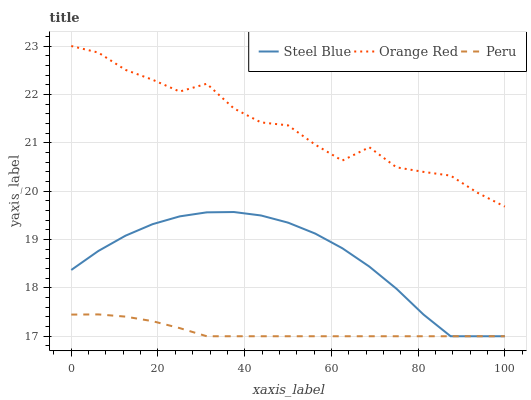Does Peru have the minimum area under the curve?
Answer yes or no. Yes. Does Orange Red have the maximum area under the curve?
Answer yes or no. Yes. Does Orange Red have the minimum area under the curve?
Answer yes or no. No. Does Peru have the maximum area under the curve?
Answer yes or no. No. Is Peru the smoothest?
Answer yes or no. Yes. Is Orange Red the roughest?
Answer yes or no. Yes. Is Orange Red the smoothest?
Answer yes or no. No. Is Peru the roughest?
Answer yes or no. No. Does Orange Red have the lowest value?
Answer yes or no. No. Does Peru have the highest value?
Answer yes or no. No. Is Peru less than Orange Red?
Answer yes or no. Yes. Is Orange Red greater than Peru?
Answer yes or no. Yes. Does Peru intersect Orange Red?
Answer yes or no. No. 